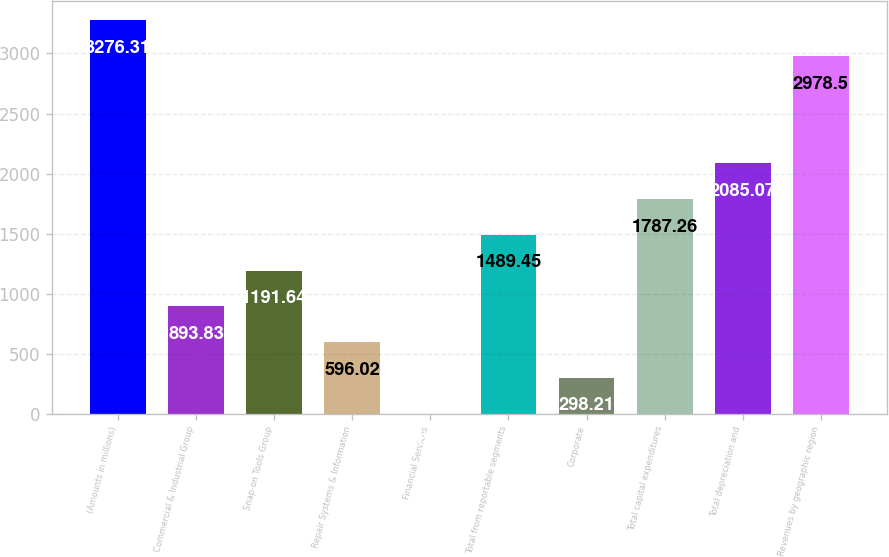Convert chart to OTSL. <chart><loc_0><loc_0><loc_500><loc_500><bar_chart><fcel>(Amounts in millions)<fcel>Commercial & Industrial Group<fcel>Snap-on Tools Group<fcel>Repair Systems & Information<fcel>Financial Services<fcel>Total from reportable segments<fcel>Corporate<fcel>Total capital expenditures<fcel>Total depreciation and<fcel>Revenues by geographic region<nl><fcel>3276.31<fcel>893.83<fcel>1191.64<fcel>596.02<fcel>0.4<fcel>1489.45<fcel>298.21<fcel>1787.26<fcel>2085.07<fcel>2978.5<nl></chart> 